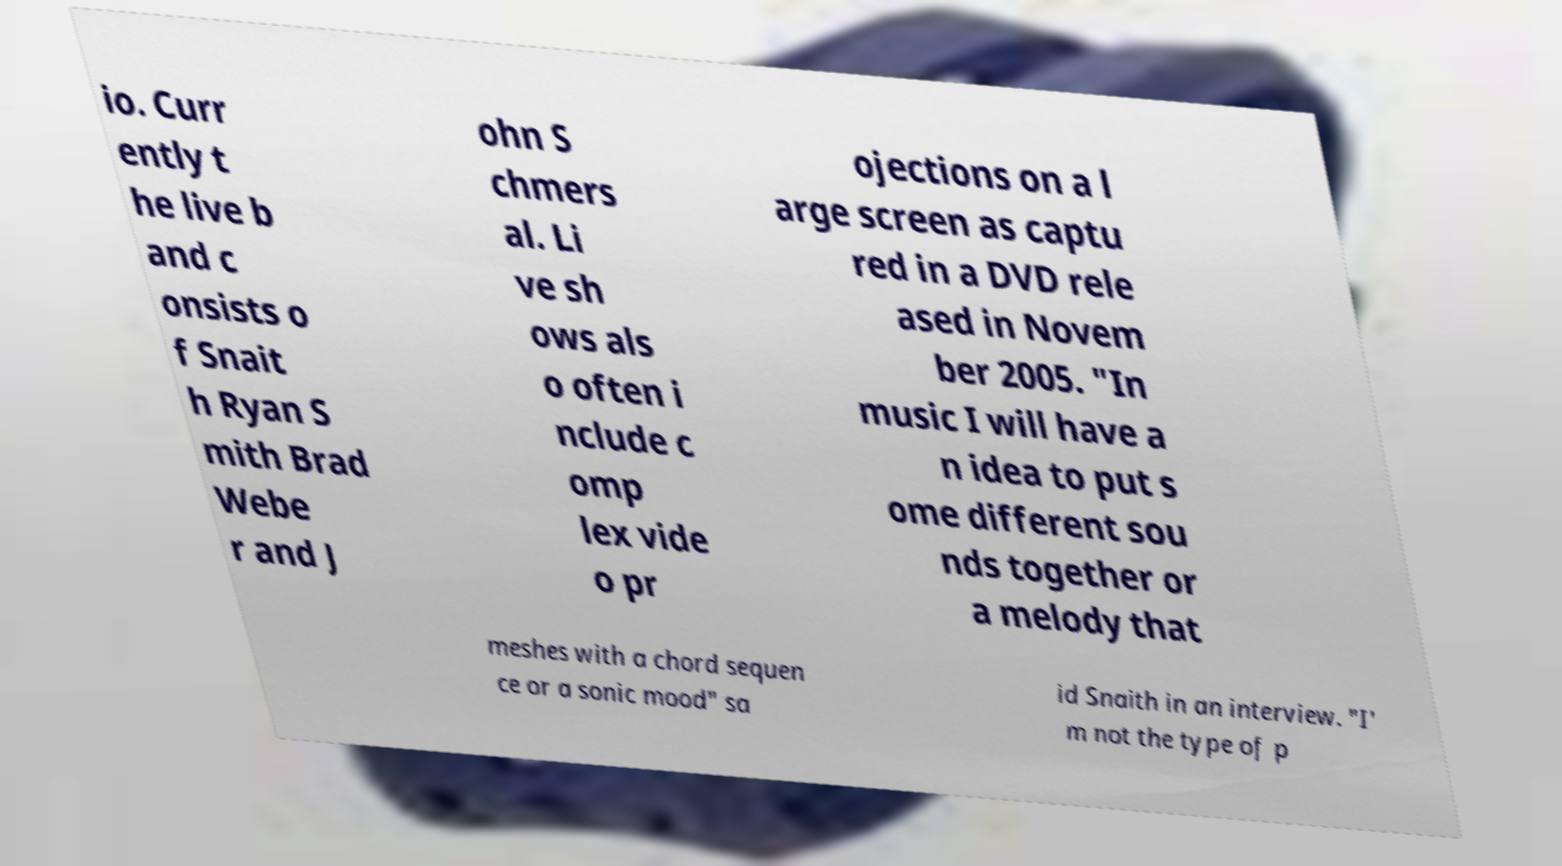Could you extract and type out the text from this image? io. Curr ently t he live b and c onsists o f Snait h Ryan S mith Brad Webe r and J ohn S chmers al. Li ve sh ows als o often i nclude c omp lex vide o pr ojections on a l arge screen as captu red in a DVD rele ased in Novem ber 2005. "In music I will have a n idea to put s ome different sou nds together or a melody that meshes with a chord sequen ce or a sonic mood" sa id Snaith in an interview. "I' m not the type of p 